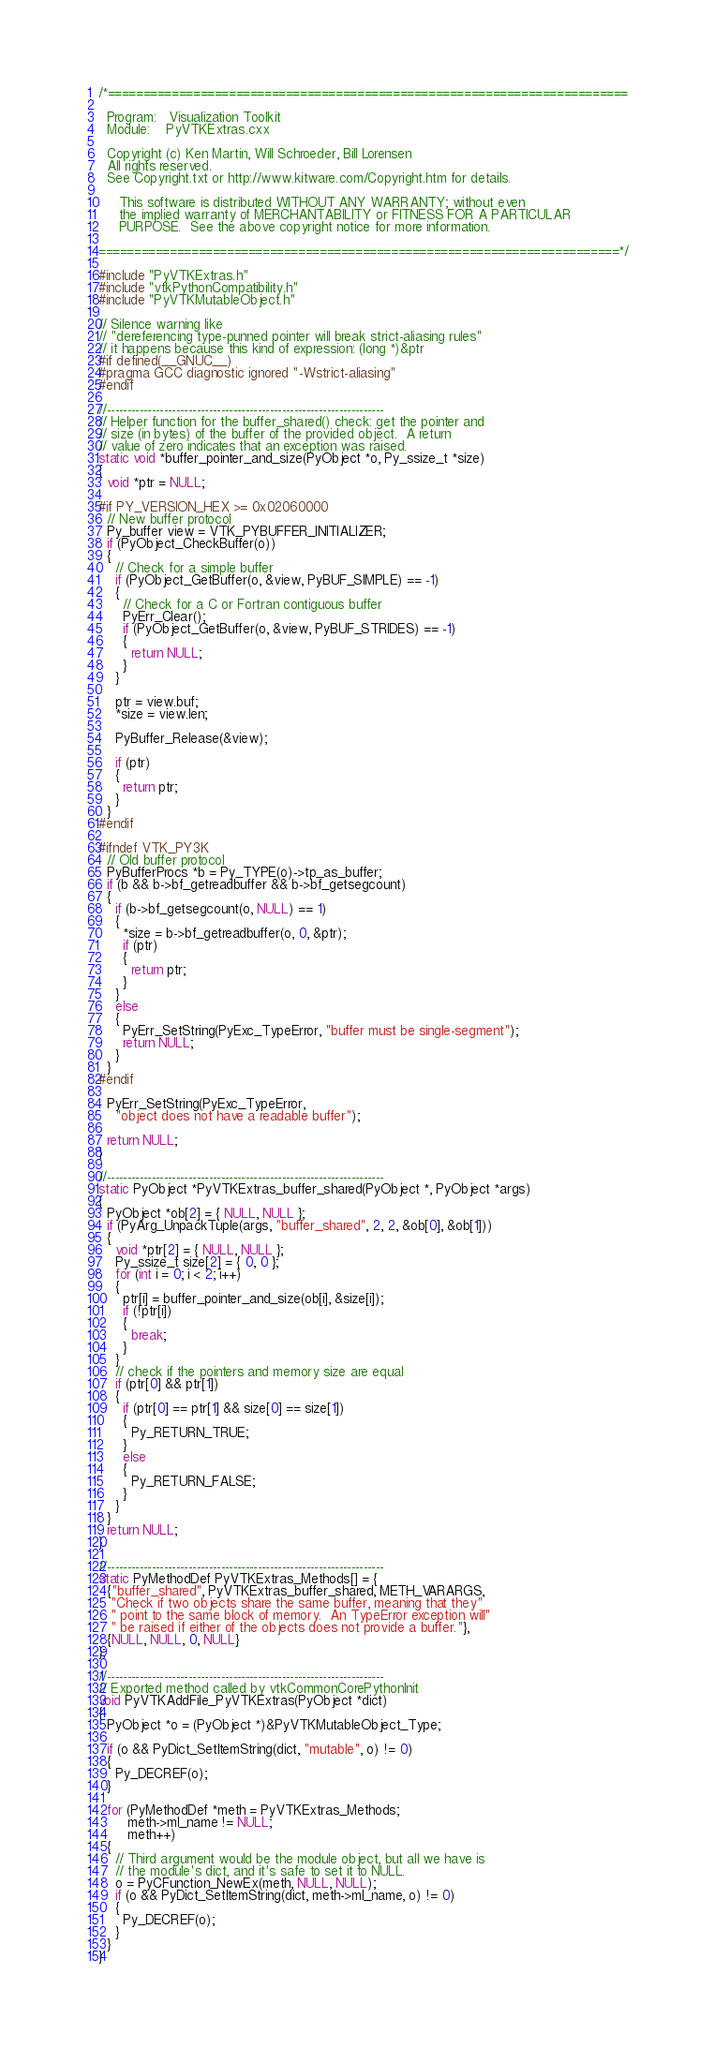Convert code to text. <code><loc_0><loc_0><loc_500><loc_500><_C++_>/*=========================================================================

  Program:   Visualization Toolkit
  Module:    PyVTKExtras.cxx

  Copyright (c) Ken Martin, Will Schroeder, Bill Lorensen
  All rights reserved.
  See Copyright.txt or http://www.kitware.com/Copyright.htm for details.

     This software is distributed WITHOUT ANY WARRANTY; without even
     the implied warranty of MERCHANTABILITY or FITNESS FOR A PARTICULAR
     PURPOSE.  See the above copyright notice for more information.

=========================================================================*/

#include "PyVTKExtras.h"
#include "vtkPythonCompatibility.h"
#include "PyVTKMutableObject.h"

// Silence warning like
// "dereferencing type-punned pointer will break strict-aliasing rules"
// it happens because this kind of expression: (long *)&ptr
#if defined(__GNUC__)
#pragma GCC diagnostic ignored "-Wstrict-aliasing"
#endif

//--------------------------------------------------------------------
// Helper function for the buffer_shared() check: get the pointer and
// size (in bytes) of the buffer of the provided object.  A return
// value of zero indicates that an exception was raised.
static void *buffer_pointer_and_size(PyObject *o, Py_ssize_t *size)
{
  void *ptr = NULL;

#if PY_VERSION_HEX >= 0x02060000
  // New buffer protocol
  Py_buffer view = VTK_PYBUFFER_INITIALIZER;
  if (PyObject_CheckBuffer(o))
  {
    // Check for a simple buffer
    if (PyObject_GetBuffer(o, &view, PyBUF_SIMPLE) == -1)
    {
      // Check for a C or Fortran contiguous buffer
      PyErr_Clear();
      if (PyObject_GetBuffer(o, &view, PyBUF_STRIDES) == -1)
      {
        return NULL;
      }
    }

    ptr = view.buf;
    *size = view.len;

    PyBuffer_Release(&view);

    if (ptr)
    {
      return ptr;
    }
  }
#endif

#ifndef VTK_PY3K
  // Old buffer protocol
  PyBufferProcs *b = Py_TYPE(o)->tp_as_buffer;
  if (b && b->bf_getreadbuffer && b->bf_getsegcount)
  {
    if (b->bf_getsegcount(o, NULL) == 1)
    {
      *size = b->bf_getreadbuffer(o, 0, &ptr);
      if (ptr)
      {
        return ptr;
      }
    }
    else
    {
      PyErr_SetString(PyExc_TypeError, "buffer must be single-segment");
      return NULL;
    }
  }
#endif

  PyErr_SetString(PyExc_TypeError,
    "object does not have a readable buffer");

  return NULL;
}

//--------------------------------------------------------------------
static PyObject *PyVTKExtras_buffer_shared(PyObject *, PyObject *args)
{
  PyObject *ob[2] = { NULL, NULL };
  if (PyArg_UnpackTuple(args, "buffer_shared", 2, 2, &ob[0], &ob[1]))
  {
    void *ptr[2] = { NULL, NULL };
    Py_ssize_t size[2] = { 0, 0 };
    for (int i = 0; i < 2; i++)
    {
      ptr[i] = buffer_pointer_and_size(ob[i], &size[i]);
      if (!ptr[i])
      {
        break;
      }
    }
    // check if the pointers and memory size are equal
    if (ptr[0] && ptr[1])
    {
      if (ptr[0] == ptr[1] && size[0] == size[1])
      {
        Py_RETURN_TRUE;
      }
      else
      {
        Py_RETURN_FALSE;
      }
    }
  }
  return NULL;
}

//--------------------------------------------------------------------
static PyMethodDef PyVTKExtras_Methods[] = {
  {"buffer_shared", PyVTKExtras_buffer_shared, METH_VARARGS,
   "Check if two objects share the same buffer, meaning that they"
   " point to the same block of memory.  An TypeError exception will"
   " be raised if either of the objects does not provide a buffer."},
  {NULL, NULL, 0, NULL}
};

//--------------------------------------------------------------------
// Exported method called by vtkCommonCorePythonInit
void PyVTKAddFile_PyVTKExtras(PyObject *dict)
{
  PyObject *o = (PyObject *)&PyVTKMutableObject_Type;

  if (o && PyDict_SetItemString(dict, "mutable", o) != 0)
  {
    Py_DECREF(o);
  }

  for (PyMethodDef *meth = PyVTKExtras_Methods;
       meth->ml_name != NULL;
       meth++)
  {
    // Third argument would be the module object, but all we have is
    // the module's dict, and it's safe to set it to NULL.
    o = PyCFunction_NewEx(meth, NULL, NULL);
    if (o && PyDict_SetItemString(dict, meth->ml_name, o) != 0)
    {
      Py_DECREF(o);
    }
  }
}
</code> 